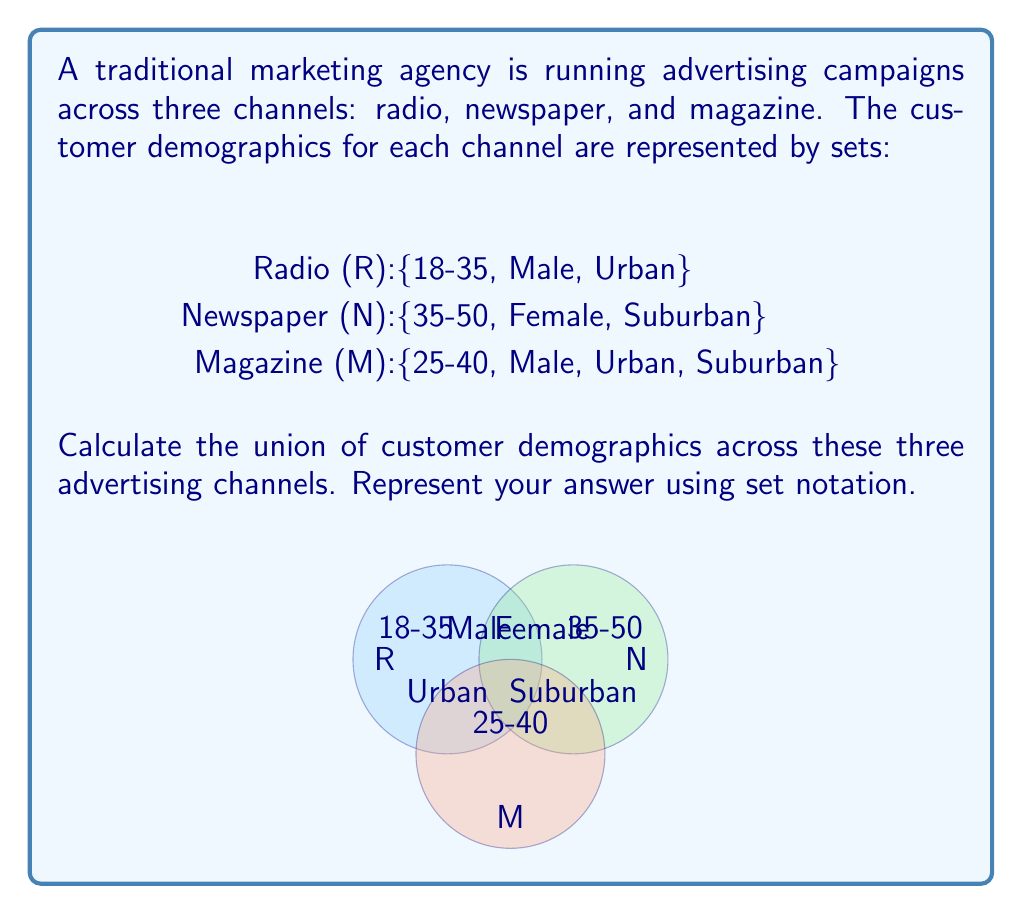Can you answer this question? To calculate the union of customer demographics across the three advertising channels, we need to combine all unique elements from each set. Let's approach this step-by-step:

1. First, let's list out all the elements in each set:
   R = {18-35, Male, Urban}
   N = {35-50, Female, Suburban}
   M = {25-40, Male, Urban, Suburban}

2. The union operation (∪) combines all unique elements from all sets. We can represent this as R ∪ N ∪ M.

3. Let's start combining elements, noting any duplicates:
   - Age groups: 18-35, 35-50, 25-40
   - Gender: Male, Female
   - Location: Urban, Suburban

4. We can see that there are no exact duplicates, so all elements will be included in the union.

5. To represent this in set notation, we use curly braces {} and list all unique elements separated by commas.

Therefore, the union of customer demographics across these three advertising channels is:
$$ R \cup N \cup M = \{18-35, 35-50, 25-40, Male, Female, Urban, Suburban\} $$

This set represents the combined target audience across all three channels, encompassing all age groups, genders, and locations targeted by the marketing campaign.
Answer: $$ \{18-35, 35-50, 25-40, Male, Female, Urban, Suburban\} $$ 